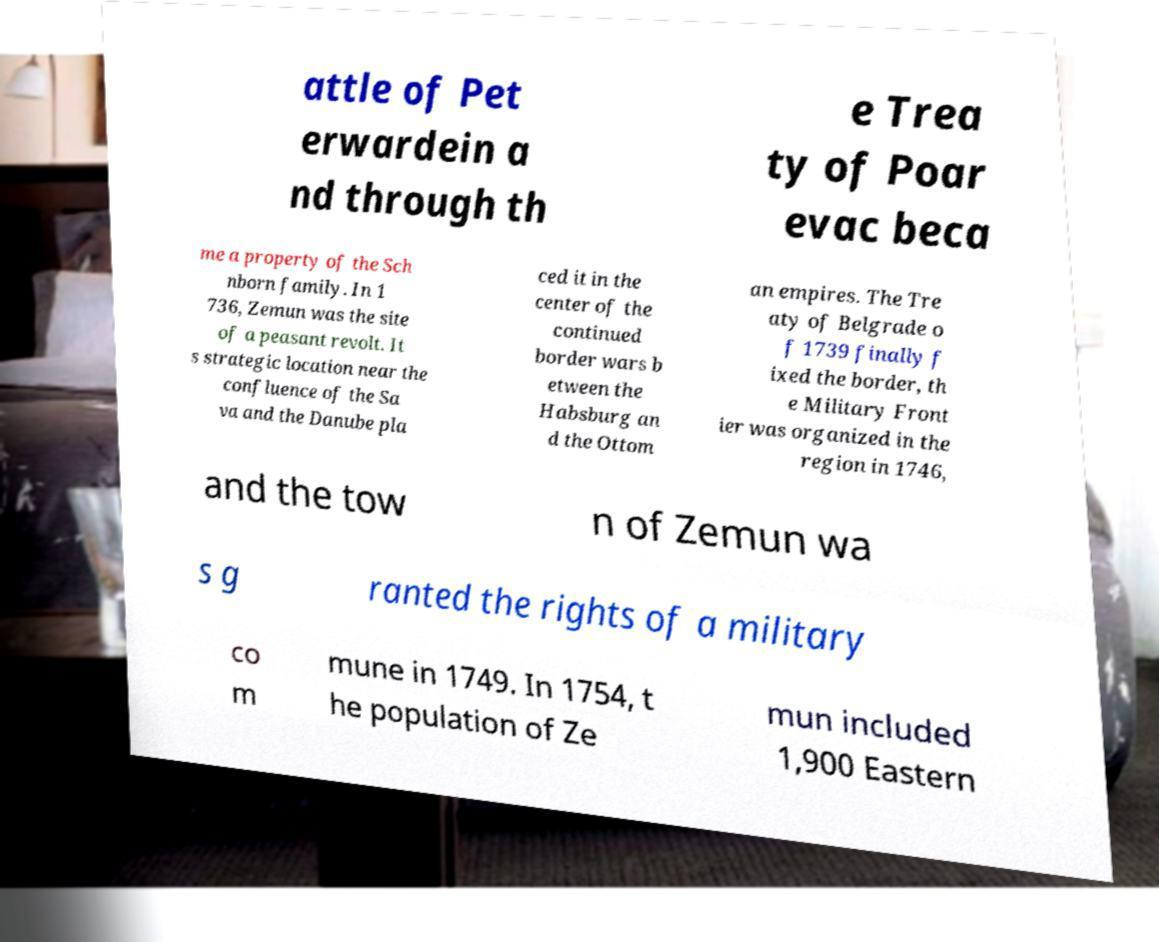Can you read and provide the text displayed in the image?This photo seems to have some interesting text. Can you extract and type it out for me? attle of Pet erwardein a nd through th e Trea ty of Poar evac beca me a property of the Sch nborn family. In 1 736, Zemun was the site of a peasant revolt. It s strategic location near the confluence of the Sa va and the Danube pla ced it in the center of the continued border wars b etween the Habsburg an d the Ottom an empires. The Tre aty of Belgrade o f 1739 finally f ixed the border, th e Military Front ier was organized in the region in 1746, and the tow n of Zemun wa s g ranted the rights of a military co m mune in 1749. In 1754, t he population of Ze mun included 1,900 Eastern 